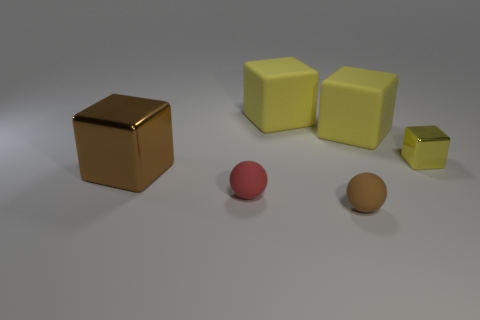What size is the rubber ball that is the same color as the big metal thing?
Your response must be concise. Small. Are there any other things that have the same shape as the tiny brown object?
Offer a terse response. Yes. What is the color of the metal block that is the same size as the brown rubber ball?
Make the answer very short. Yellow. Is the number of large yellow blocks on the right side of the small yellow object less than the number of red balls that are in front of the tiny red thing?
Provide a short and direct response. No. Does the yellow object that is on the left side of the brown rubber ball have the same size as the small yellow shiny cube?
Your answer should be very brief. No. There is a metal thing that is behind the large brown thing; what is its shape?
Make the answer very short. Cube. Are there more tiny rubber things than red spheres?
Ensure brevity in your answer.  Yes. Is the color of the cube in front of the tiny yellow thing the same as the tiny shiny cube?
Provide a short and direct response. No. How many things are tiny metal things that are right of the big metallic cube or yellow objects that are to the left of the small brown sphere?
Make the answer very short. 2. What number of shiny cubes are left of the red ball and right of the brown rubber sphere?
Keep it short and to the point. 0. 